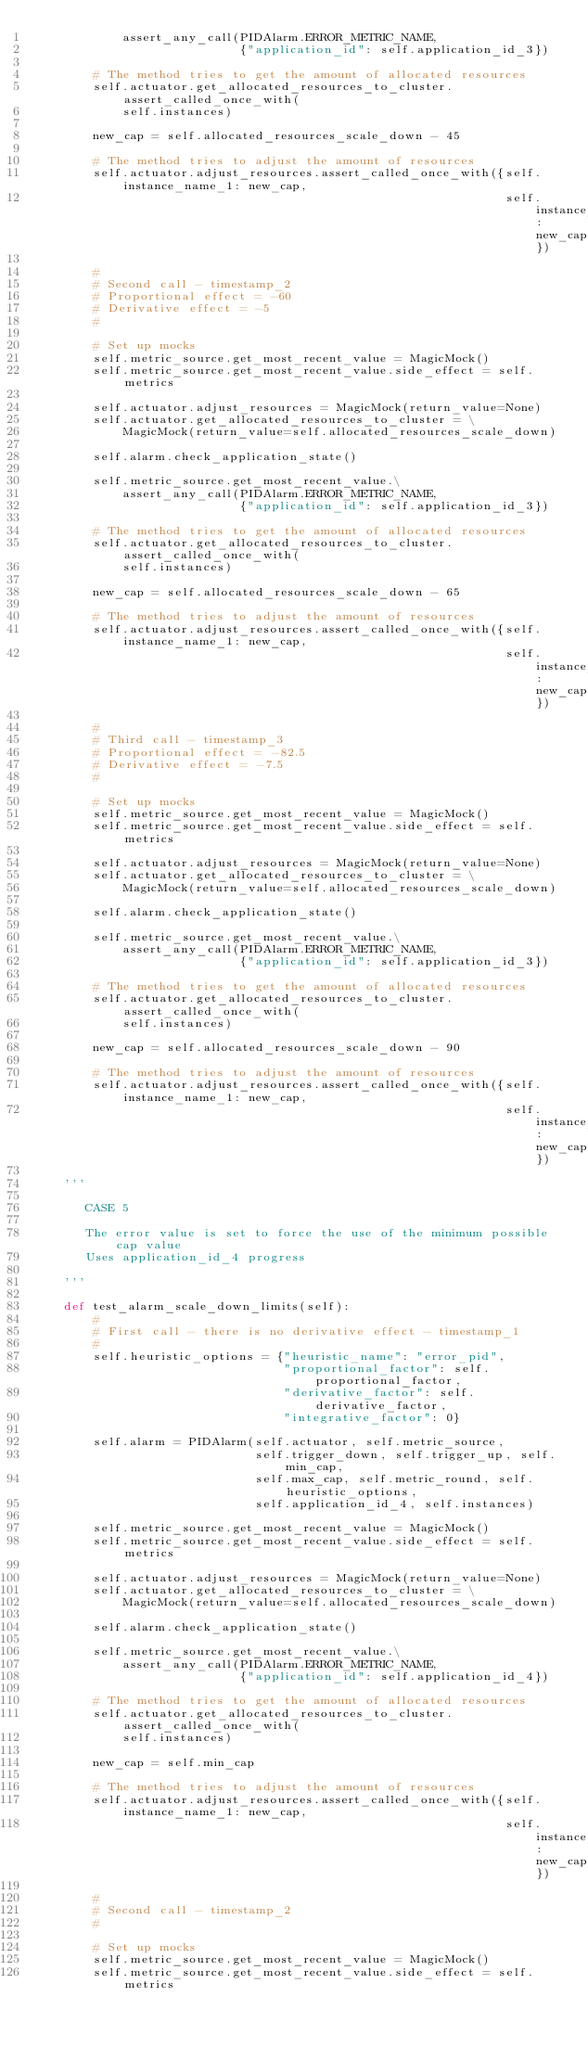<code> <loc_0><loc_0><loc_500><loc_500><_Python_>            assert_any_call(PIDAlarm.ERROR_METRIC_NAME,
                            {"application_id": self.application_id_3})

        # The method tries to get the amount of allocated resources
        self.actuator.get_allocated_resources_to_cluster.assert_called_once_with(
            self.instances)

        new_cap = self.allocated_resources_scale_down - 45

        # The method tries to adjust the amount of resources
        self.actuator.adjust_resources.assert_called_once_with({self.instance_name_1: new_cap,
                                                                self.instance_name_2: new_cap})

        #
        # Second call - timestamp_2
        # Proportional effect = -60
        # Derivative effect = -5
        #

        # Set up mocks
        self.metric_source.get_most_recent_value = MagicMock()
        self.metric_source.get_most_recent_value.side_effect = self.metrics

        self.actuator.adjust_resources = MagicMock(return_value=None)
        self.actuator.get_allocated_resources_to_cluster = \
            MagicMock(return_value=self.allocated_resources_scale_down)

        self.alarm.check_application_state()

        self.metric_source.get_most_recent_value.\
            assert_any_call(PIDAlarm.ERROR_METRIC_NAME,
                            {"application_id": self.application_id_3})

        # The method tries to get the amount of allocated resources
        self.actuator.get_allocated_resources_to_cluster.assert_called_once_with(
            self.instances)

        new_cap = self.allocated_resources_scale_down - 65

        # The method tries to adjust the amount of resources
        self.actuator.adjust_resources.assert_called_once_with({self.instance_name_1: new_cap,
                                                                self.instance_name_2: new_cap})

        #
        # Third call - timestamp_3
        # Proportional effect = -82.5
        # Derivative effect = -7.5
        #

        # Set up mocks
        self.metric_source.get_most_recent_value = MagicMock()
        self.metric_source.get_most_recent_value.side_effect = self.metrics

        self.actuator.adjust_resources = MagicMock(return_value=None)
        self.actuator.get_allocated_resources_to_cluster = \
            MagicMock(return_value=self.allocated_resources_scale_down)

        self.alarm.check_application_state()

        self.metric_source.get_most_recent_value.\
            assert_any_call(PIDAlarm.ERROR_METRIC_NAME,
                            {"application_id": self.application_id_3})

        # The method tries to get the amount of allocated resources
        self.actuator.get_allocated_resources_to_cluster.assert_called_once_with(
            self.instances)

        new_cap = self.allocated_resources_scale_down - 90

        # The method tries to adjust the amount of resources
        self.actuator.adjust_resources.assert_called_once_with({self.instance_name_1: new_cap,
                                                                self.instance_name_2: new_cap})

    '''

       CASE 5

       The error value is set to force the use of the minimum possible cap value
       Uses application_id_4 progress

    '''

    def test_alarm_scale_down_limits(self):
        #
        # First call - there is no derivative effect - timestamp_1
        #
        self.heuristic_options = {"heuristic_name": "error_pid",
                                  "proportional_factor": self.proportional_factor,
                                  "derivative_factor": self.derivative_factor,
                                  "integrative_factor": 0}

        self.alarm = PIDAlarm(self.actuator, self.metric_source,
                              self.trigger_down, self.trigger_up, self.min_cap,
                              self.max_cap, self.metric_round, self.heuristic_options,
                              self.application_id_4, self.instances)

        self.metric_source.get_most_recent_value = MagicMock()
        self.metric_source.get_most_recent_value.side_effect = self.metrics

        self.actuator.adjust_resources = MagicMock(return_value=None)
        self.actuator.get_allocated_resources_to_cluster = \
            MagicMock(return_value=self.allocated_resources_scale_down)

        self.alarm.check_application_state()

        self.metric_source.get_most_recent_value.\
            assert_any_call(PIDAlarm.ERROR_METRIC_NAME,
                            {"application_id": self.application_id_4})

        # The method tries to get the amount of allocated resources
        self.actuator.get_allocated_resources_to_cluster.assert_called_once_with(
            self.instances)

        new_cap = self.min_cap

        # The method tries to adjust the amount of resources
        self.actuator.adjust_resources.assert_called_once_with({self.instance_name_1: new_cap,
                                                                self.instance_name_2: new_cap})

        #
        # Second call - timestamp_2
        #

        # Set up mocks
        self.metric_source.get_most_recent_value = MagicMock()
        self.metric_source.get_most_recent_value.side_effect = self.metrics
</code> 